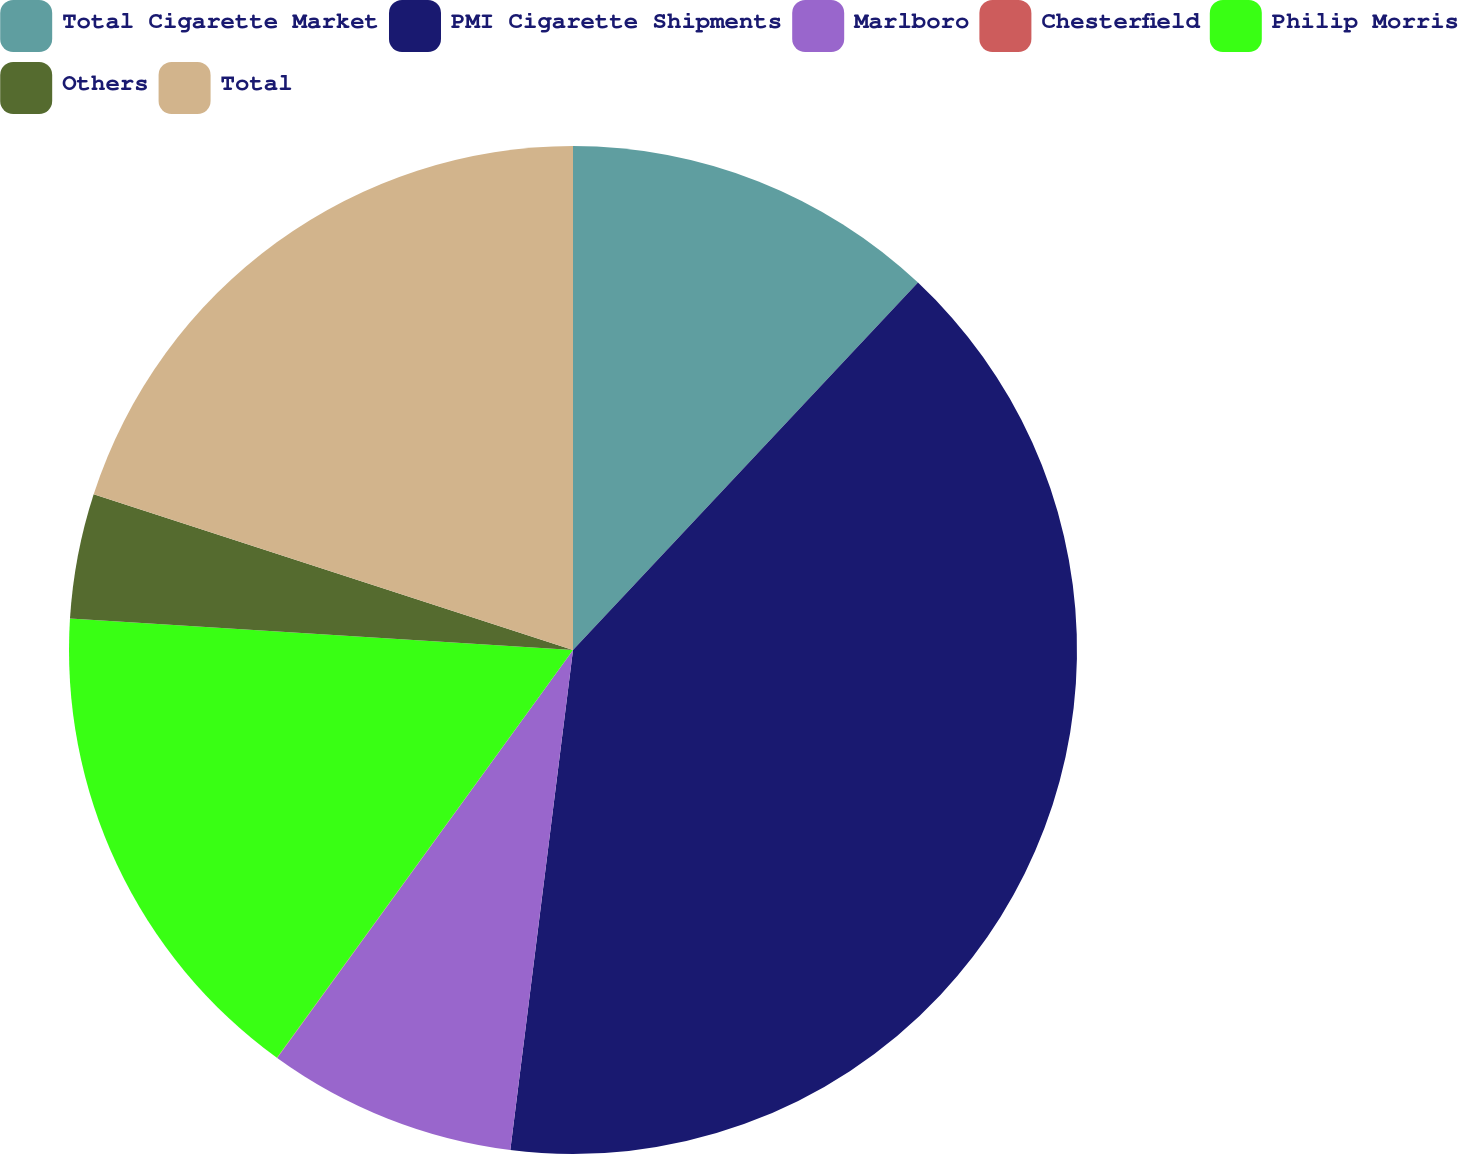Convert chart to OTSL. <chart><loc_0><loc_0><loc_500><loc_500><pie_chart><fcel>Total Cigarette Market<fcel>PMI Cigarette Shipments<fcel>Marlboro<fcel>Chesterfield<fcel>Philip Morris<fcel>Others<fcel>Total<nl><fcel>12.0%<fcel>39.99%<fcel>8.0%<fcel>0.01%<fcel>16.0%<fcel>4.01%<fcel>20.0%<nl></chart> 